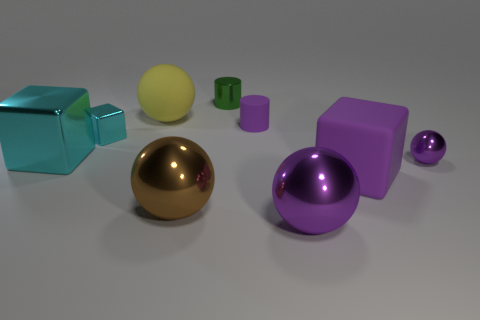Add 1 small shiny cubes. How many objects exist? 10 Subtract all cylinders. How many objects are left? 7 Add 8 large purple matte cubes. How many large purple matte cubes exist? 9 Subtract 1 brown balls. How many objects are left? 8 Subtract all brown metal spheres. Subtract all large cyan objects. How many objects are left? 7 Add 8 purple blocks. How many purple blocks are left? 9 